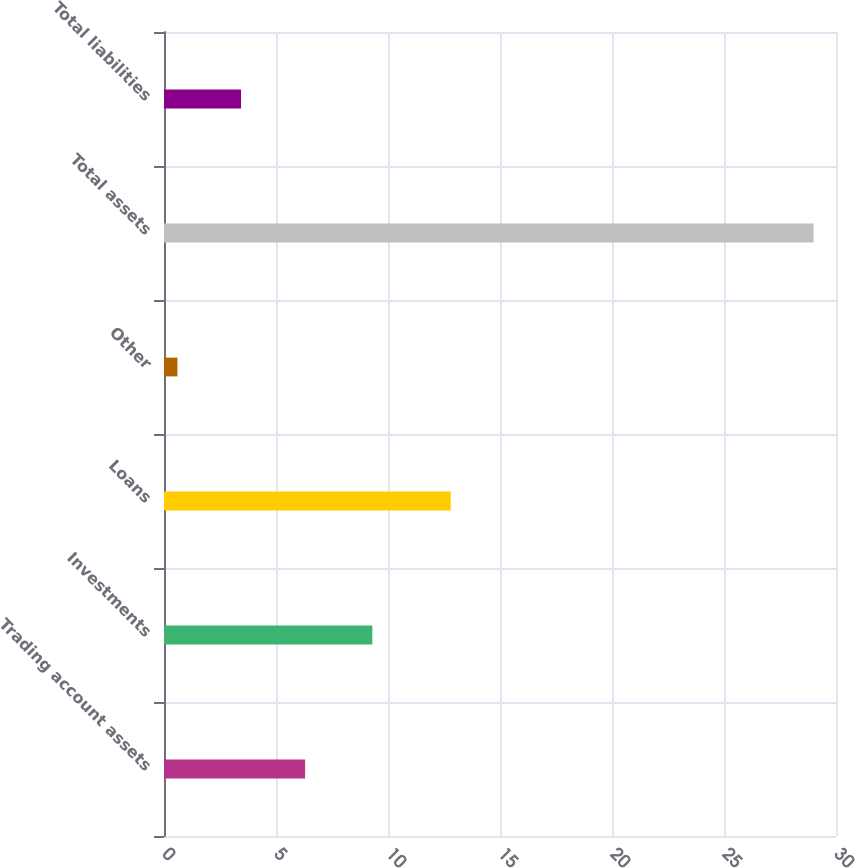Convert chart. <chart><loc_0><loc_0><loc_500><loc_500><bar_chart><fcel>Trading account assets<fcel>Investments<fcel>Loans<fcel>Other<fcel>Total assets<fcel>Total liabilities<nl><fcel>6.3<fcel>9.3<fcel>12.8<fcel>0.6<fcel>29<fcel>3.44<nl></chart> 